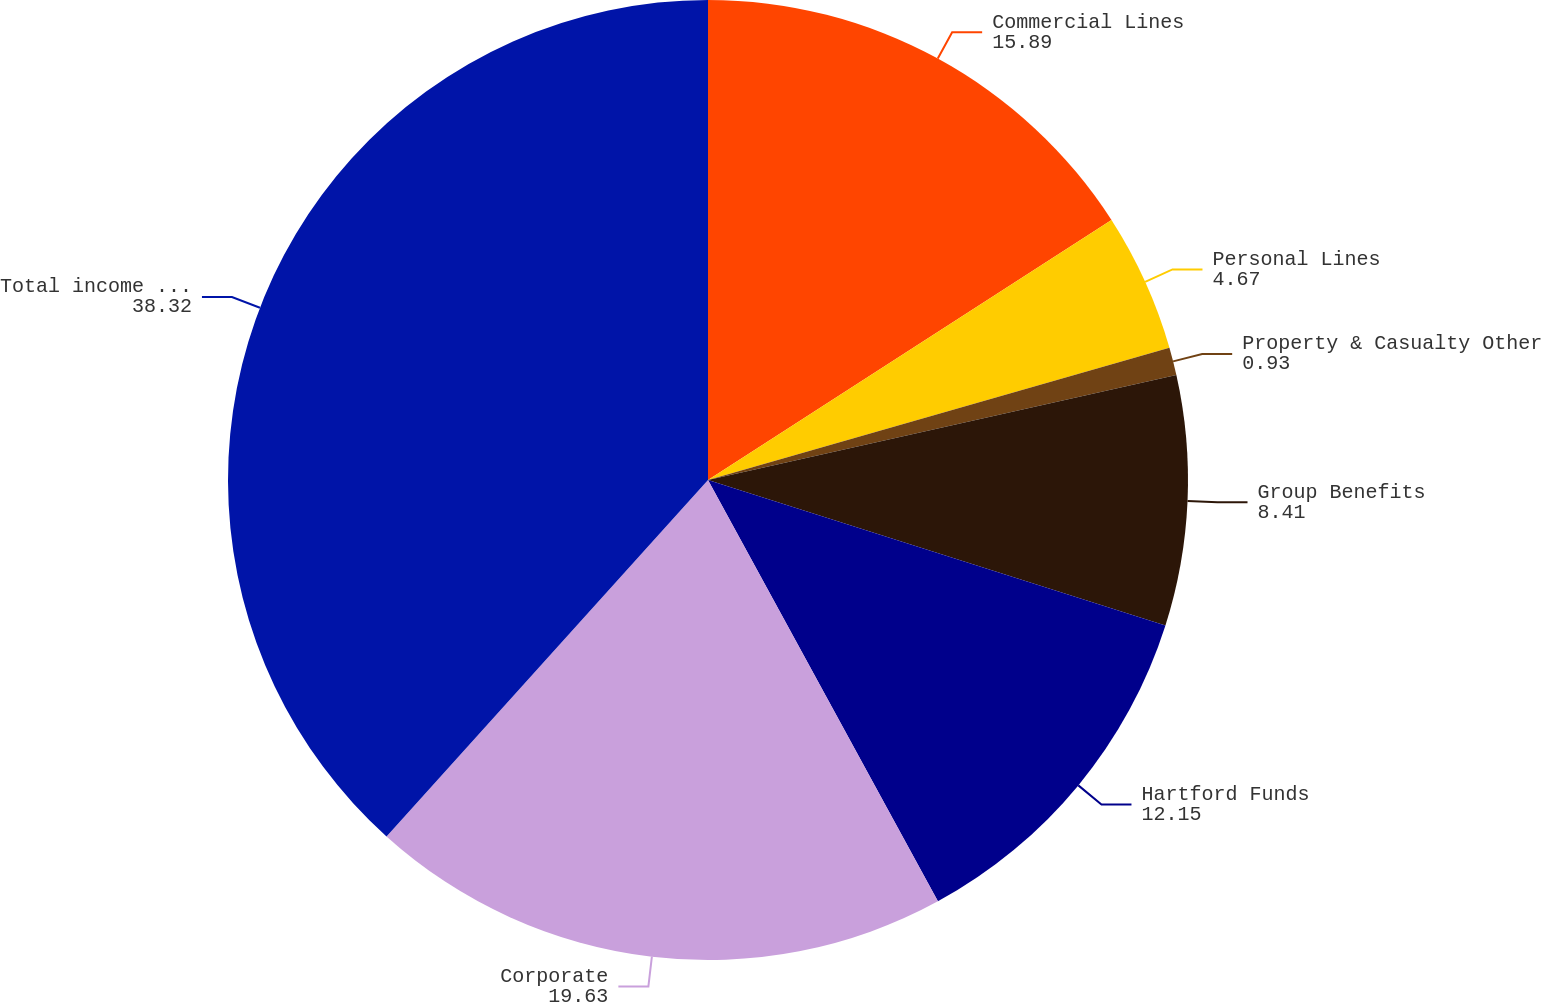Convert chart. <chart><loc_0><loc_0><loc_500><loc_500><pie_chart><fcel>Commercial Lines<fcel>Personal Lines<fcel>Property & Casualty Other<fcel>Group Benefits<fcel>Hartford Funds<fcel>Corporate<fcel>Total income tax expense<nl><fcel>15.89%<fcel>4.67%<fcel>0.93%<fcel>8.41%<fcel>12.15%<fcel>19.63%<fcel>38.32%<nl></chart> 